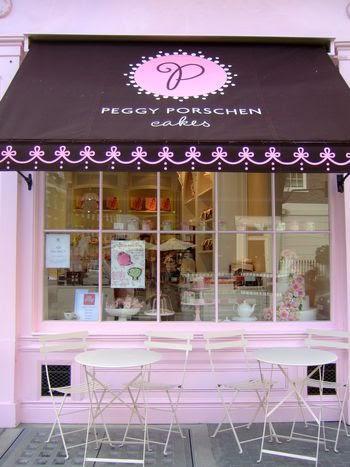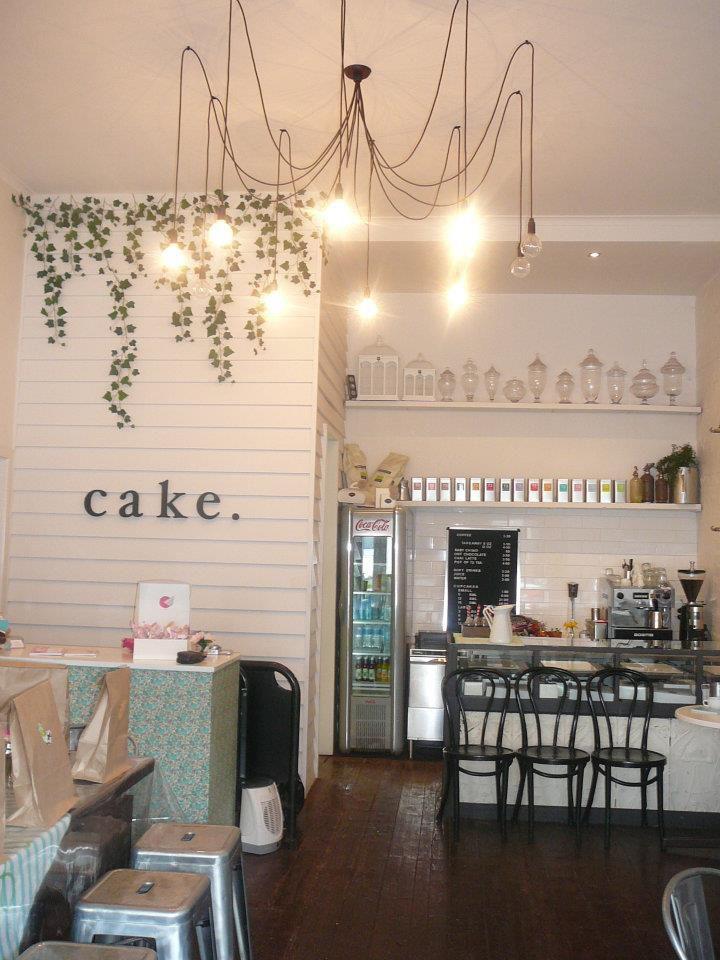The first image is the image on the left, the second image is the image on the right. Assess this claim about the two images: "An image contains a view of a storefront from an outside perspective.". Correct or not? Answer yes or no. Yes. The first image is the image on the left, the second image is the image on the right. Considering the images on both sides, is "There are tables and chairs for the customers." valid? Answer yes or no. Yes. 